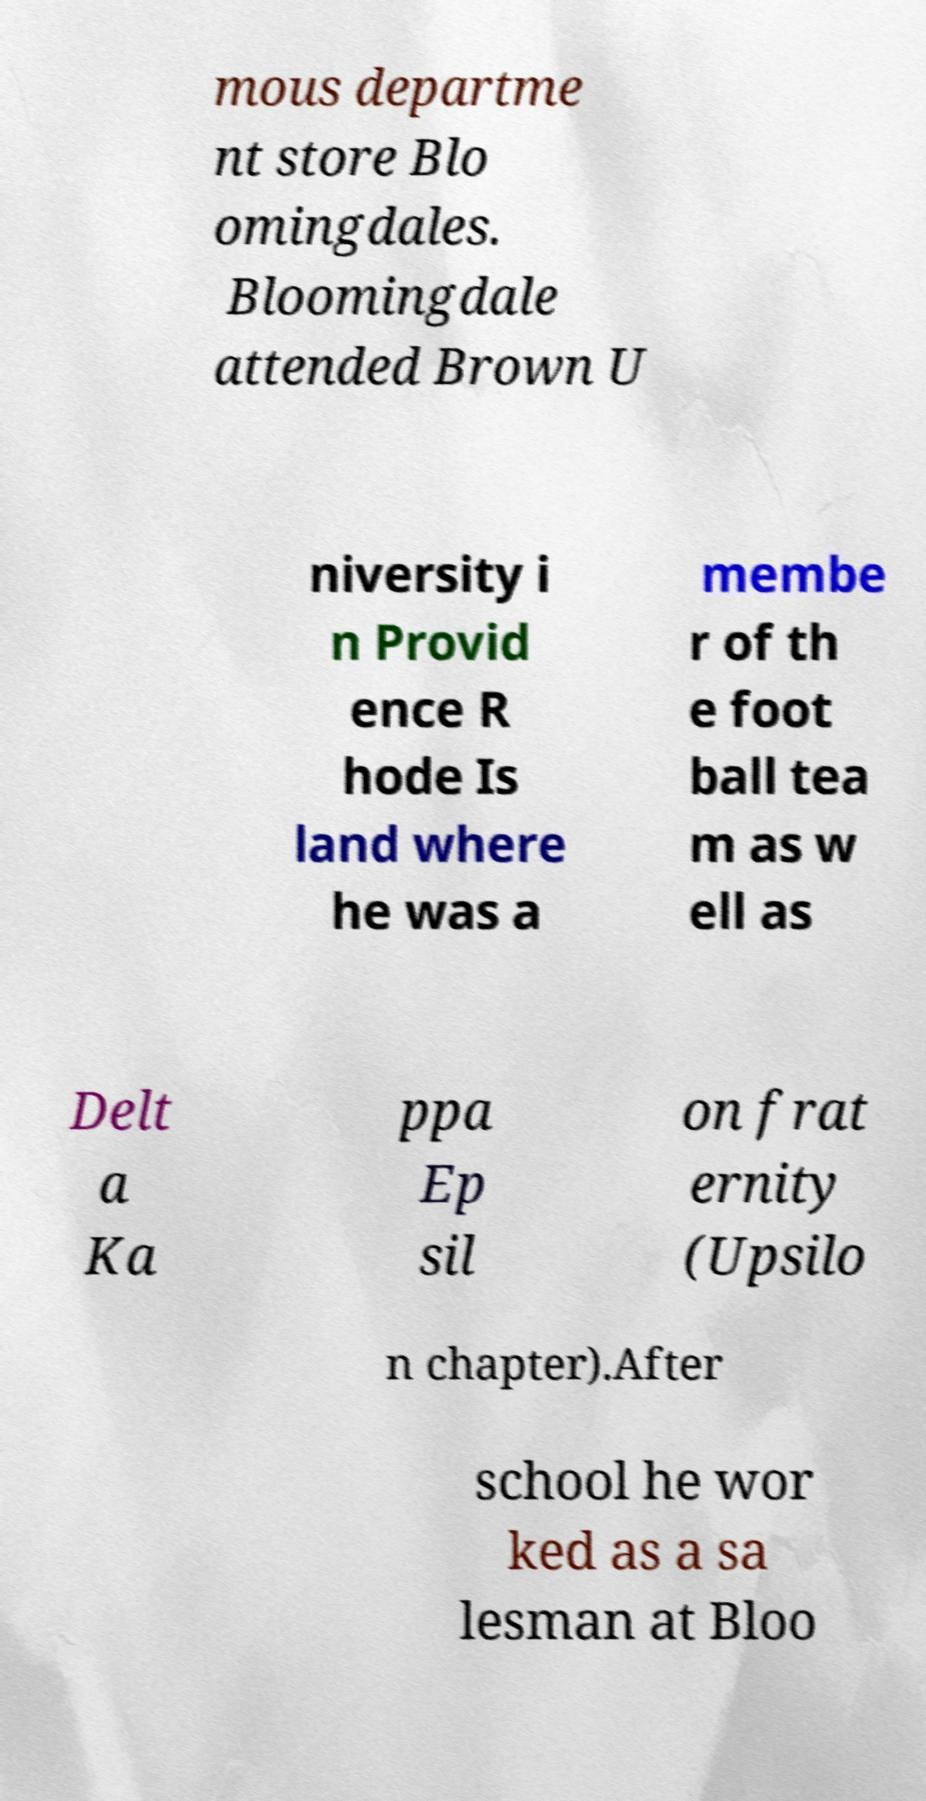Could you assist in decoding the text presented in this image and type it out clearly? mous departme nt store Blo omingdales. Bloomingdale attended Brown U niversity i n Provid ence R hode Is land where he was a membe r of th e foot ball tea m as w ell as Delt a Ka ppa Ep sil on frat ernity (Upsilo n chapter).After school he wor ked as a sa lesman at Bloo 